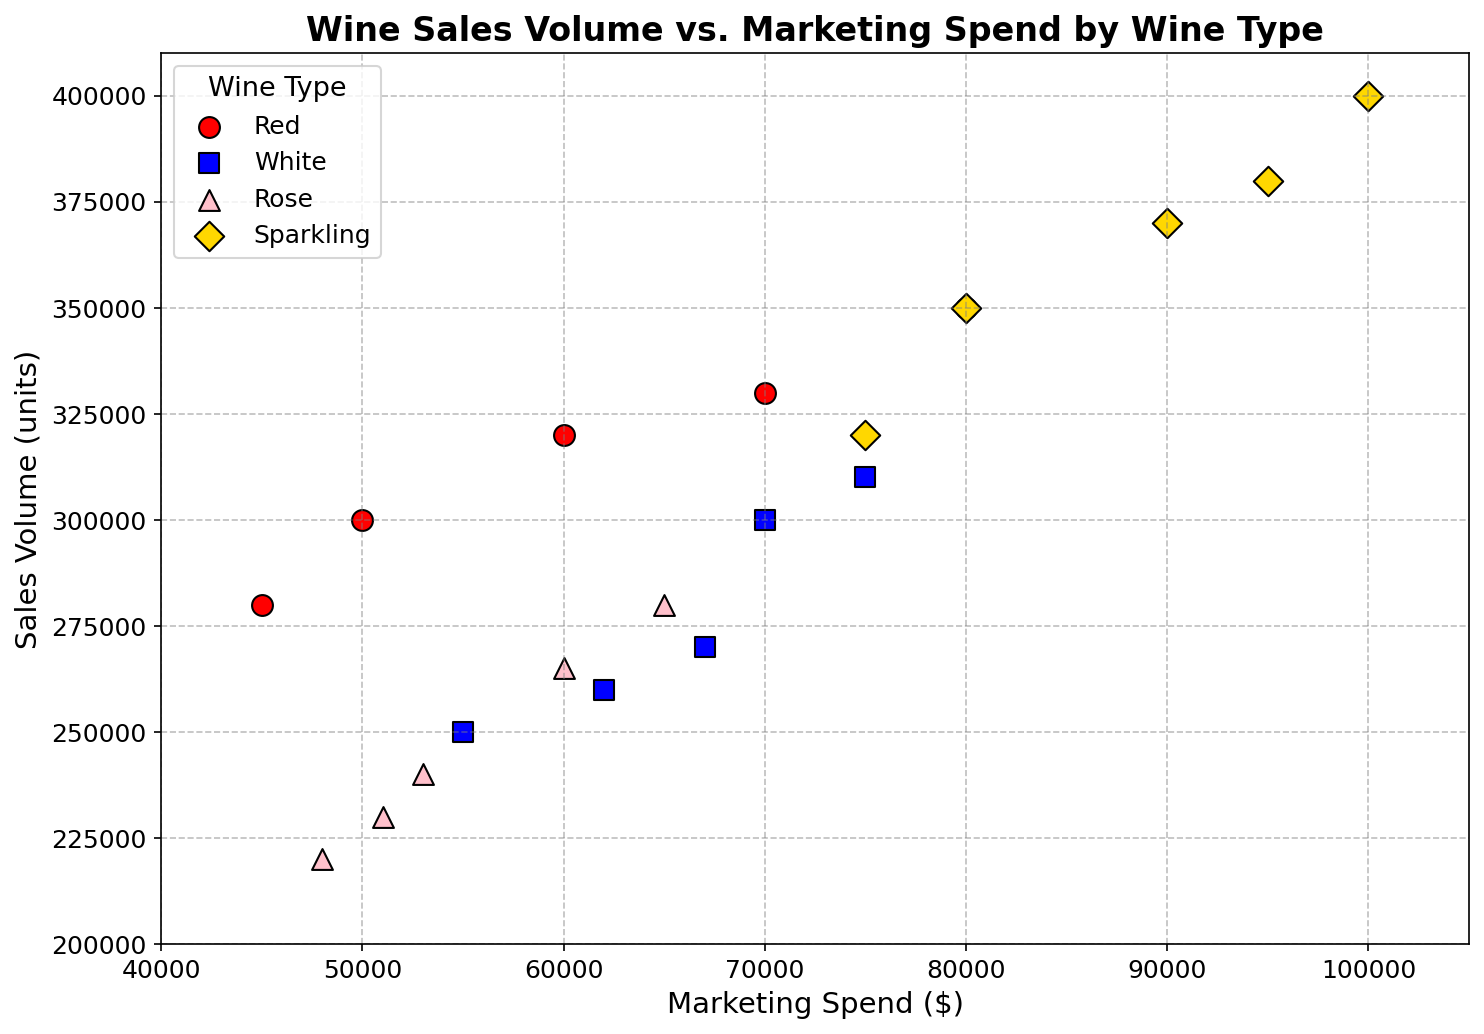what is the average sales volume for Red wine? Add up all the sales volumes for Red wine: (300000 + 320000 + 280000 + 350000 + 330000) = 1580000. Then divide by the number of data points, which is 5. So, 1580000 / 5 = 316000.
Answer: 316000 Which wine type had the highest single sales volume? Look at the highest points on the y-axis for each color. The highest point is for Sparkling wine, which is 400000.
Answer: Sparkling Do Red wines tend to have higher marketing spend than White wines? Compare the average or typical values for marketing spend between red and white data points. Red wines have marketing spends mostly between 45000 and 80000, while White wines have marketing spends also in a similar range but slightly overlapping. No clear trend that Reds are higher.
Answer: No What is the difference in the highest sales volume between Rose and Sparkling wines? The highest sales volume for Rose is 280000, while for Sparkling it is 400000. Calculate the difference: 400000 - 280000 = 120000.
Answer: 120000 For which wine type is the range of sales volumes the smallest? Check the difference between the highest and lowest sales volumes for each wine type. The ranges are: Red (350000-280000=70000), White (310000-250000=60000), Rose (280000-220000=60000), Sparkling (400000-320000=80000). White and Rose have the smallest ranges.
Answer: White and Rose Based on visual inspection, which wine type shows the most consistent relationship between marketing spend and sales volume? Check for the linearly increasing patterns. Sparkling shows a very consistent linearly increasing relationship between marketing spend and sales volume.
Answer: Sparkling Compare the marketing spend for the highest sales volume of Red and White wines. Which is higher? The highest sales volume for Red wine is 350000 with marketing spend 80000. For White wine, it is 310000 with marketing spend 75000. The marketing spend is higher for Red.
Answer: Red Is there any wine type where the marketing spend does not clearly relate to the sales volume? By looking at the scatter plot for any scattered patterns without a clear trend. Red and White wine types show such scattered patterns where the relationship is not very clear.
Answer: Red and White What is the sum of the lowest sales volume for Rose and White wines? Find the lowest sales volumes for Rose (220000) and White (250000) and sum them up: 220000 + 250000 = 470000.
Answer: 470000 What is the common range of marketing spend for all wine types? Compare the range of marketing spend values across all types. All wine types have marketing spends ranging approximately between 45000 and 100000.
Answer: 45000-100000 